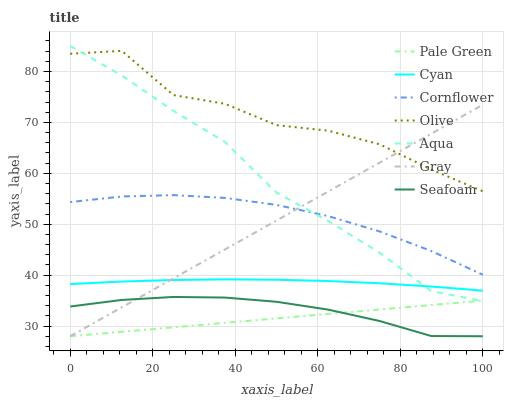Does Pale Green have the minimum area under the curve?
Answer yes or no. Yes. Does Olive have the maximum area under the curve?
Answer yes or no. Yes. Does Cornflower have the minimum area under the curve?
Answer yes or no. No. Does Cornflower have the maximum area under the curve?
Answer yes or no. No. Is Pale Green the smoothest?
Answer yes or no. Yes. Is Olive the roughest?
Answer yes or no. Yes. Is Cornflower the smoothest?
Answer yes or no. No. Is Cornflower the roughest?
Answer yes or no. No. Does Cornflower have the lowest value?
Answer yes or no. No. Does Cornflower have the highest value?
Answer yes or no. No. Is Cyan less than Olive?
Answer yes or no. Yes. Is Cornflower greater than Cyan?
Answer yes or no. Yes. Does Cyan intersect Olive?
Answer yes or no. No. 